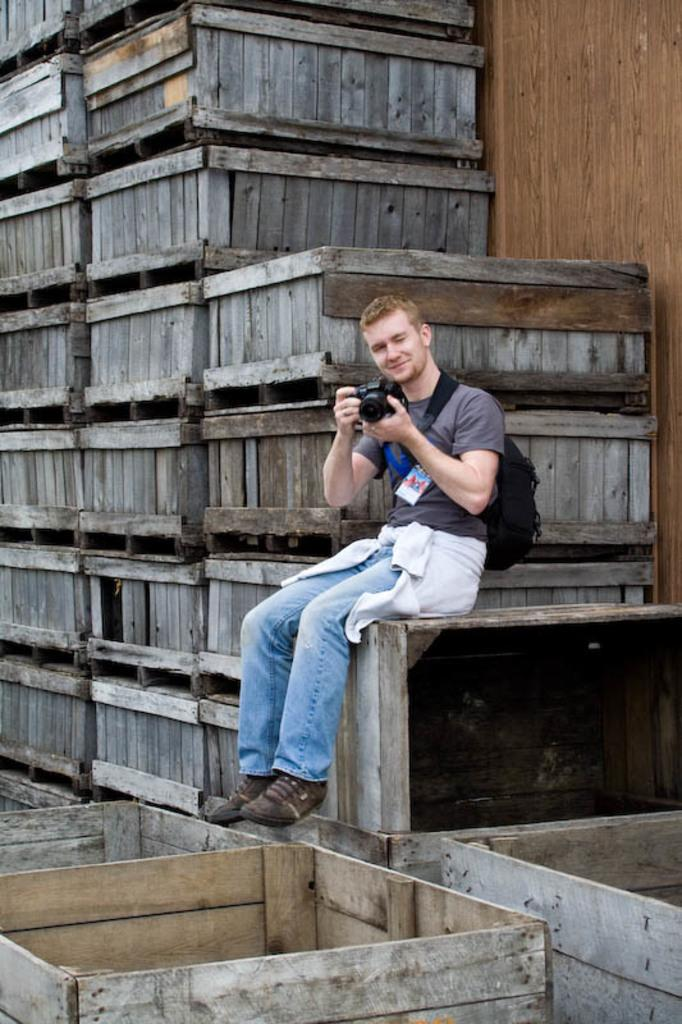What is the person in the image doing? The person is sitting in the image and holding a camera in his hands. What might the person be planning to do with the camera? The person might be planning to take photographs with the camera. What objects are located near the person? There are wooden boxes at the side of the person. What type of profit can be seen in the image? There is no mention of profit in the image; it features a person sitting and holding a camera, along with wooden boxes nearby. 